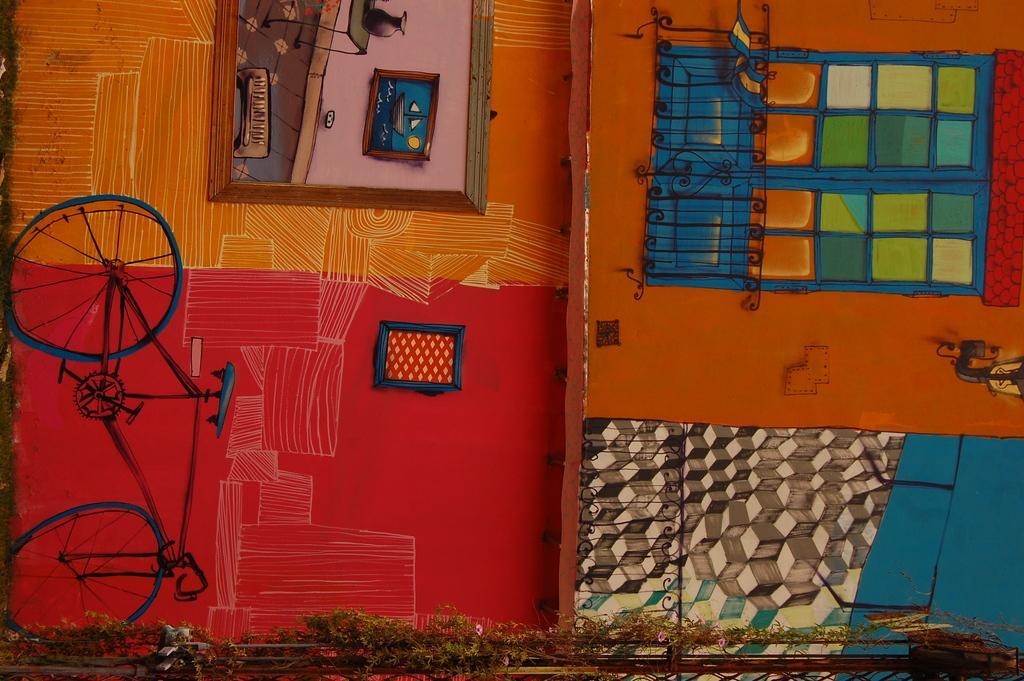Describe this image in one or two sentences. In this image I can see a frame attached to the wall and on the wall I can see few paintings and they are in multi color. 